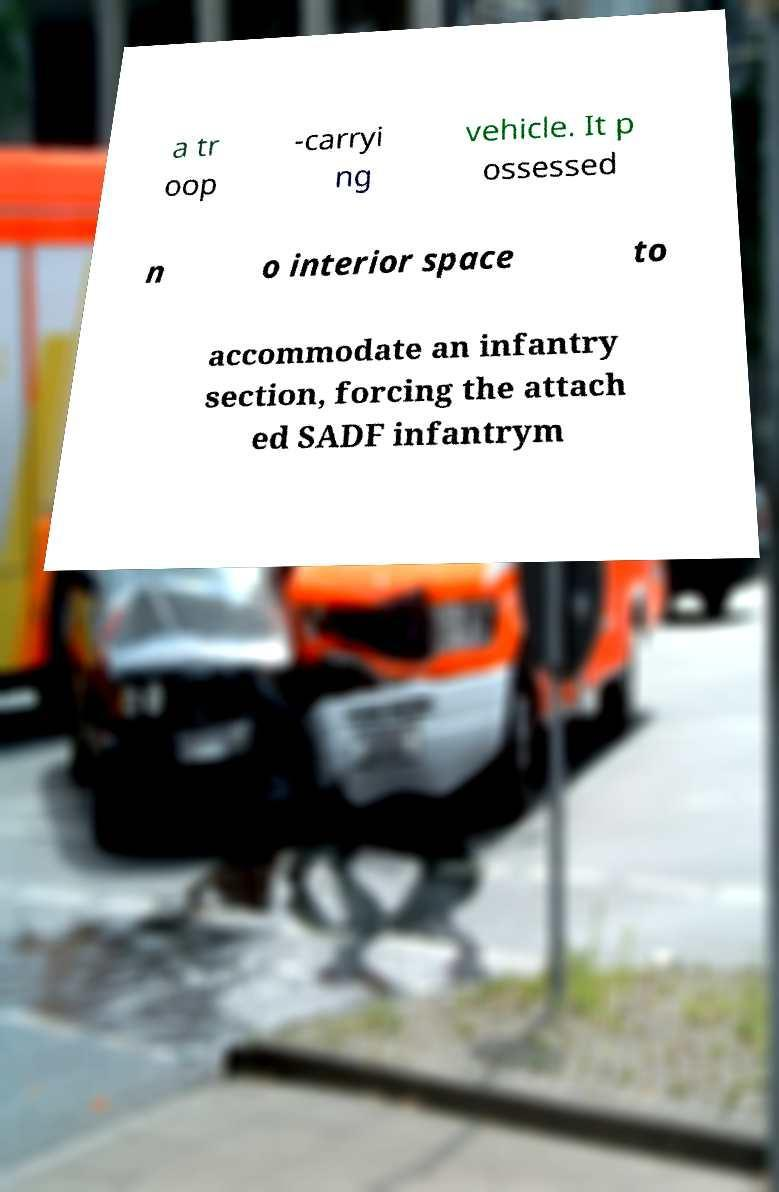I need the written content from this picture converted into text. Can you do that? a tr oop -carryi ng vehicle. It p ossessed n o interior space to accommodate an infantry section, forcing the attach ed SADF infantrym 